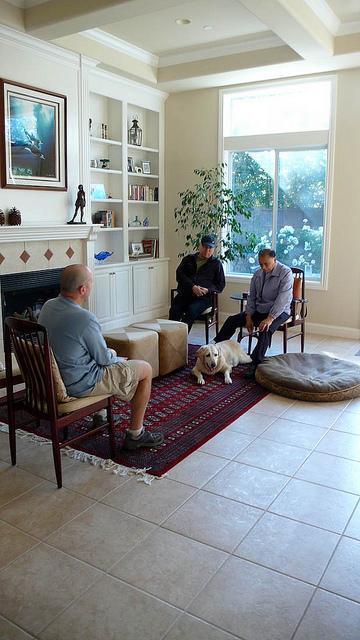How many people are there?
Give a very brief answer. 3. How many of the people on the bench are holding umbrellas ?
Give a very brief answer. 0. 